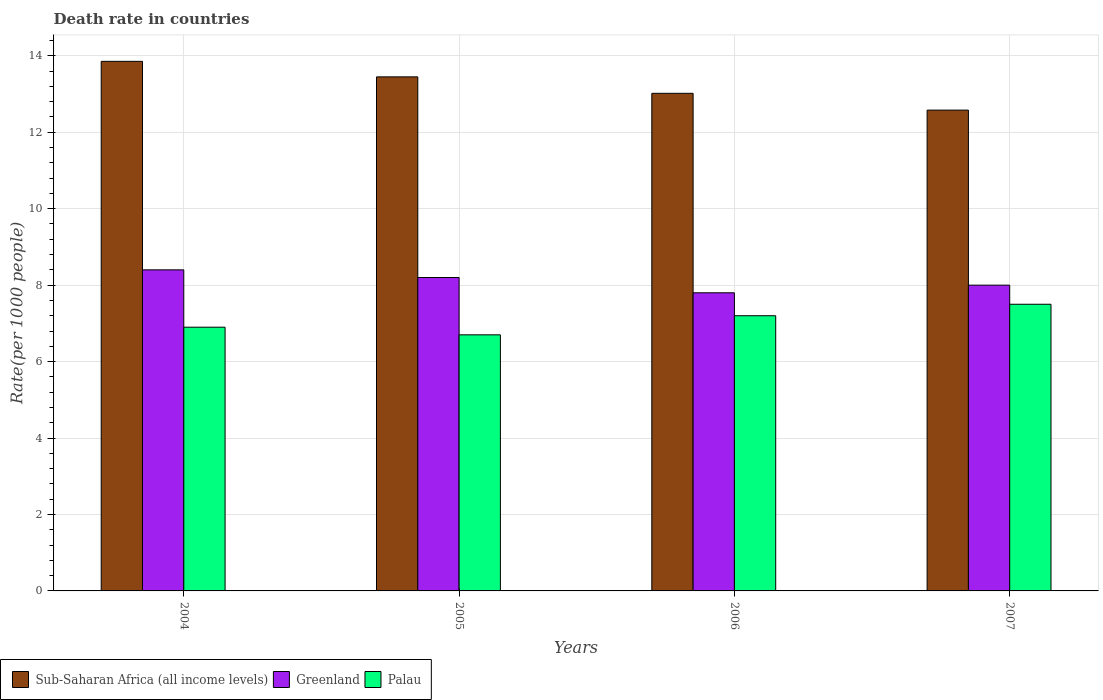How many groups of bars are there?
Your answer should be very brief. 4. Are the number of bars on each tick of the X-axis equal?
Your response must be concise. Yes. What is the label of the 4th group of bars from the left?
Provide a short and direct response. 2007. Across all years, what is the maximum death rate in Greenland?
Your answer should be compact. 8.4. Across all years, what is the minimum death rate in Greenland?
Make the answer very short. 7.8. What is the total death rate in Greenland in the graph?
Provide a short and direct response. 32.4. What is the difference between the death rate in Sub-Saharan Africa (all income levels) in 2005 and that in 2007?
Make the answer very short. 0.87. What is the difference between the death rate in Greenland in 2007 and the death rate in Palau in 2004?
Provide a short and direct response. 1.1. What is the average death rate in Greenland per year?
Your answer should be very brief. 8.1. In the year 2005, what is the difference between the death rate in Sub-Saharan Africa (all income levels) and death rate in Palau?
Give a very brief answer. 6.75. What is the ratio of the death rate in Greenland in 2004 to that in 2006?
Provide a short and direct response. 1.08. Is the death rate in Palau in 2005 less than that in 2007?
Make the answer very short. Yes. Is the difference between the death rate in Sub-Saharan Africa (all income levels) in 2005 and 2006 greater than the difference between the death rate in Palau in 2005 and 2006?
Your answer should be very brief. Yes. What is the difference between the highest and the second highest death rate in Sub-Saharan Africa (all income levels)?
Provide a short and direct response. 0.41. What is the difference between the highest and the lowest death rate in Greenland?
Provide a short and direct response. 0.6. Is the sum of the death rate in Palau in 2004 and 2005 greater than the maximum death rate in Greenland across all years?
Your answer should be very brief. Yes. What does the 2nd bar from the left in 2005 represents?
Your answer should be compact. Greenland. What does the 1st bar from the right in 2005 represents?
Ensure brevity in your answer.  Palau. Is it the case that in every year, the sum of the death rate in Greenland and death rate in Sub-Saharan Africa (all income levels) is greater than the death rate in Palau?
Keep it short and to the point. Yes. How many bars are there?
Your answer should be very brief. 12. Are all the bars in the graph horizontal?
Give a very brief answer. No. Does the graph contain any zero values?
Ensure brevity in your answer.  No. Does the graph contain grids?
Provide a succinct answer. Yes. What is the title of the graph?
Provide a short and direct response. Death rate in countries. What is the label or title of the Y-axis?
Provide a succinct answer. Rate(per 1000 people). What is the Rate(per 1000 people) in Sub-Saharan Africa (all income levels) in 2004?
Your answer should be compact. 13.86. What is the Rate(per 1000 people) of Greenland in 2004?
Ensure brevity in your answer.  8.4. What is the Rate(per 1000 people) in Sub-Saharan Africa (all income levels) in 2005?
Your answer should be very brief. 13.45. What is the Rate(per 1000 people) of Palau in 2005?
Make the answer very short. 6.7. What is the Rate(per 1000 people) in Sub-Saharan Africa (all income levels) in 2006?
Your answer should be compact. 13.02. What is the Rate(per 1000 people) in Sub-Saharan Africa (all income levels) in 2007?
Your answer should be very brief. 12.58. What is the Rate(per 1000 people) of Palau in 2007?
Your answer should be very brief. 7.5. Across all years, what is the maximum Rate(per 1000 people) in Sub-Saharan Africa (all income levels)?
Provide a short and direct response. 13.86. Across all years, what is the maximum Rate(per 1000 people) in Palau?
Your response must be concise. 7.5. Across all years, what is the minimum Rate(per 1000 people) in Sub-Saharan Africa (all income levels)?
Provide a short and direct response. 12.58. Across all years, what is the minimum Rate(per 1000 people) of Greenland?
Provide a succinct answer. 7.8. What is the total Rate(per 1000 people) of Sub-Saharan Africa (all income levels) in the graph?
Ensure brevity in your answer.  52.9. What is the total Rate(per 1000 people) in Greenland in the graph?
Provide a short and direct response. 32.4. What is the total Rate(per 1000 people) of Palau in the graph?
Offer a very short reply. 28.3. What is the difference between the Rate(per 1000 people) in Sub-Saharan Africa (all income levels) in 2004 and that in 2005?
Your answer should be very brief. 0.41. What is the difference between the Rate(per 1000 people) in Sub-Saharan Africa (all income levels) in 2004 and that in 2006?
Your response must be concise. 0.84. What is the difference between the Rate(per 1000 people) in Greenland in 2004 and that in 2006?
Your response must be concise. 0.6. What is the difference between the Rate(per 1000 people) in Palau in 2004 and that in 2006?
Offer a very short reply. -0.3. What is the difference between the Rate(per 1000 people) of Sub-Saharan Africa (all income levels) in 2004 and that in 2007?
Your response must be concise. 1.28. What is the difference between the Rate(per 1000 people) of Greenland in 2004 and that in 2007?
Offer a terse response. 0.4. What is the difference between the Rate(per 1000 people) in Palau in 2004 and that in 2007?
Offer a terse response. -0.6. What is the difference between the Rate(per 1000 people) in Sub-Saharan Africa (all income levels) in 2005 and that in 2006?
Offer a terse response. 0.43. What is the difference between the Rate(per 1000 people) in Greenland in 2005 and that in 2006?
Offer a terse response. 0.4. What is the difference between the Rate(per 1000 people) in Sub-Saharan Africa (all income levels) in 2005 and that in 2007?
Your response must be concise. 0.87. What is the difference between the Rate(per 1000 people) in Palau in 2005 and that in 2007?
Provide a succinct answer. -0.8. What is the difference between the Rate(per 1000 people) of Sub-Saharan Africa (all income levels) in 2006 and that in 2007?
Provide a short and direct response. 0.44. What is the difference between the Rate(per 1000 people) in Greenland in 2006 and that in 2007?
Ensure brevity in your answer.  -0.2. What is the difference between the Rate(per 1000 people) in Sub-Saharan Africa (all income levels) in 2004 and the Rate(per 1000 people) in Greenland in 2005?
Provide a short and direct response. 5.66. What is the difference between the Rate(per 1000 people) in Sub-Saharan Africa (all income levels) in 2004 and the Rate(per 1000 people) in Palau in 2005?
Provide a short and direct response. 7.16. What is the difference between the Rate(per 1000 people) in Sub-Saharan Africa (all income levels) in 2004 and the Rate(per 1000 people) in Greenland in 2006?
Your answer should be compact. 6.06. What is the difference between the Rate(per 1000 people) of Sub-Saharan Africa (all income levels) in 2004 and the Rate(per 1000 people) of Palau in 2006?
Your answer should be compact. 6.66. What is the difference between the Rate(per 1000 people) of Greenland in 2004 and the Rate(per 1000 people) of Palau in 2006?
Keep it short and to the point. 1.2. What is the difference between the Rate(per 1000 people) of Sub-Saharan Africa (all income levels) in 2004 and the Rate(per 1000 people) of Greenland in 2007?
Offer a terse response. 5.86. What is the difference between the Rate(per 1000 people) in Sub-Saharan Africa (all income levels) in 2004 and the Rate(per 1000 people) in Palau in 2007?
Make the answer very short. 6.36. What is the difference between the Rate(per 1000 people) of Greenland in 2004 and the Rate(per 1000 people) of Palau in 2007?
Your answer should be compact. 0.9. What is the difference between the Rate(per 1000 people) in Sub-Saharan Africa (all income levels) in 2005 and the Rate(per 1000 people) in Greenland in 2006?
Your answer should be compact. 5.65. What is the difference between the Rate(per 1000 people) in Sub-Saharan Africa (all income levels) in 2005 and the Rate(per 1000 people) in Palau in 2006?
Offer a terse response. 6.25. What is the difference between the Rate(per 1000 people) in Greenland in 2005 and the Rate(per 1000 people) in Palau in 2006?
Offer a terse response. 1. What is the difference between the Rate(per 1000 people) in Sub-Saharan Africa (all income levels) in 2005 and the Rate(per 1000 people) in Greenland in 2007?
Your answer should be compact. 5.45. What is the difference between the Rate(per 1000 people) in Sub-Saharan Africa (all income levels) in 2005 and the Rate(per 1000 people) in Palau in 2007?
Your answer should be very brief. 5.95. What is the difference between the Rate(per 1000 people) of Sub-Saharan Africa (all income levels) in 2006 and the Rate(per 1000 people) of Greenland in 2007?
Ensure brevity in your answer.  5.02. What is the difference between the Rate(per 1000 people) of Sub-Saharan Africa (all income levels) in 2006 and the Rate(per 1000 people) of Palau in 2007?
Provide a short and direct response. 5.52. What is the difference between the Rate(per 1000 people) in Greenland in 2006 and the Rate(per 1000 people) in Palau in 2007?
Keep it short and to the point. 0.3. What is the average Rate(per 1000 people) in Sub-Saharan Africa (all income levels) per year?
Provide a succinct answer. 13.23. What is the average Rate(per 1000 people) in Greenland per year?
Provide a short and direct response. 8.1. What is the average Rate(per 1000 people) in Palau per year?
Your answer should be compact. 7.08. In the year 2004, what is the difference between the Rate(per 1000 people) of Sub-Saharan Africa (all income levels) and Rate(per 1000 people) of Greenland?
Keep it short and to the point. 5.46. In the year 2004, what is the difference between the Rate(per 1000 people) in Sub-Saharan Africa (all income levels) and Rate(per 1000 people) in Palau?
Your answer should be very brief. 6.96. In the year 2004, what is the difference between the Rate(per 1000 people) in Greenland and Rate(per 1000 people) in Palau?
Give a very brief answer. 1.5. In the year 2005, what is the difference between the Rate(per 1000 people) in Sub-Saharan Africa (all income levels) and Rate(per 1000 people) in Greenland?
Make the answer very short. 5.25. In the year 2005, what is the difference between the Rate(per 1000 people) in Sub-Saharan Africa (all income levels) and Rate(per 1000 people) in Palau?
Offer a very short reply. 6.75. In the year 2006, what is the difference between the Rate(per 1000 people) of Sub-Saharan Africa (all income levels) and Rate(per 1000 people) of Greenland?
Provide a succinct answer. 5.22. In the year 2006, what is the difference between the Rate(per 1000 people) in Sub-Saharan Africa (all income levels) and Rate(per 1000 people) in Palau?
Provide a succinct answer. 5.82. In the year 2007, what is the difference between the Rate(per 1000 people) in Sub-Saharan Africa (all income levels) and Rate(per 1000 people) in Greenland?
Give a very brief answer. 4.58. In the year 2007, what is the difference between the Rate(per 1000 people) in Sub-Saharan Africa (all income levels) and Rate(per 1000 people) in Palau?
Offer a terse response. 5.08. What is the ratio of the Rate(per 1000 people) in Sub-Saharan Africa (all income levels) in 2004 to that in 2005?
Provide a succinct answer. 1.03. What is the ratio of the Rate(per 1000 people) of Greenland in 2004 to that in 2005?
Your answer should be compact. 1.02. What is the ratio of the Rate(per 1000 people) of Palau in 2004 to that in 2005?
Your answer should be compact. 1.03. What is the ratio of the Rate(per 1000 people) in Sub-Saharan Africa (all income levels) in 2004 to that in 2006?
Provide a short and direct response. 1.06. What is the ratio of the Rate(per 1000 people) of Sub-Saharan Africa (all income levels) in 2004 to that in 2007?
Your answer should be compact. 1.1. What is the ratio of the Rate(per 1000 people) of Greenland in 2004 to that in 2007?
Your response must be concise. 1.05. What is the ratio of the Rate(per 1000 people) in Sub-Saharan Africa (all income levels) in 2005 to that in 2006?
Provide a short and direct response. 1.03. What is the ratio of the Rate(per 1000 people) of Greenland in 2005 to that in 2006?
Provide a succinct answer. 1.05. What is the ratio of the Rate(per 1000 people) of Palau in 2005 to that in 2006?
Ensure brevity in your answer.  0.93. What is the ratio of the Rate(per 1000 people) in Sub-Saharan Africa (all income levels) in 2005 to that in 2007?
Offer a very short reply. 1.07. What is the ratio of the Rate(per 1000 people) of Palau in 2005 to that in 2007?
Offer a terse response. 0.89. What is the ratio of the Rate(per 1000 people) in Sub-Saharan Africa (all income levels) in 2006 to that in 2007?
Offer a terse response. 1.03. What is the difference between the highest and the second highest Rate(per 1000 people) in Sub-Saharan Africa (all income levels)?
Provide a succinct answer. 0.41. What is the difference between the highest and the second highest Rate(per 1000 people) of Greenland?
Offer a very short reply. 0.2. What is the difference between the highest and the lowest Rate(per 1000 people) of Sub-Saharan Africa (all income levels)?
Provide a succinct answer. 1.28. What is the difference between the highest and the lowest Rate(per 1000 people) of Palau?
Ensure brevity in your answer.  0.8. 